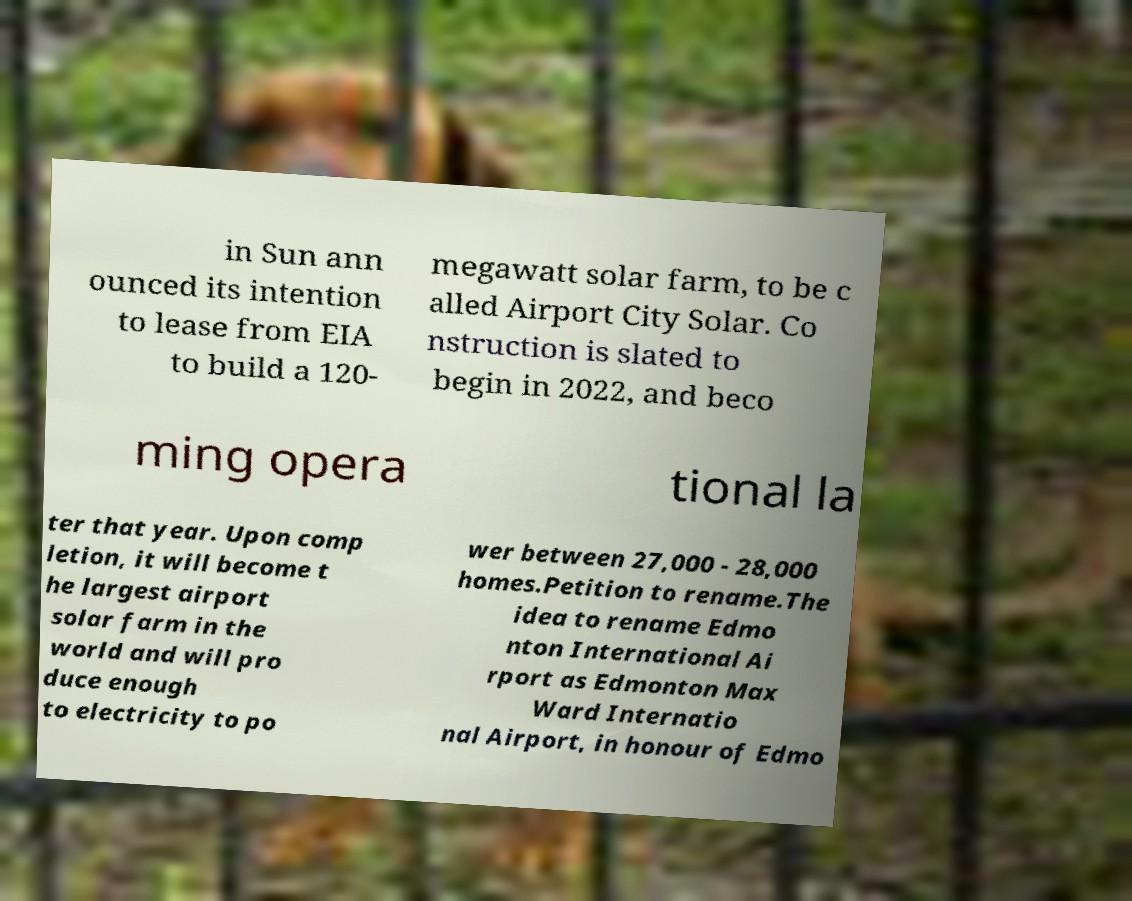Could you extract and type out the text from this image? in Sun ann ounced its intention to lease from EIA to build a 120- megawatt solar farm, to be c alled Airport City Solar. Co nstruction is slated to begin in 2022, and beco ming opera tional la ter that year. Upon comp letion, it will become t he largest airport solar farm in the world and will pro duce enough to electricity to po wer between 27,000 - 28,000 homes.Petition to rename.The idea to rename Edmo nton International Ai rport as Edmonton Max Ward Internatio nal Airport, in honour of Edmo 